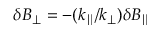Convert formula to latex. <formula><loc_0><loc_0><loc_500><loc_500>\delta B _ { \perp } = - ( k _ { \| } / k _ { \perp } ) \delta B _ { \| }</formula> 